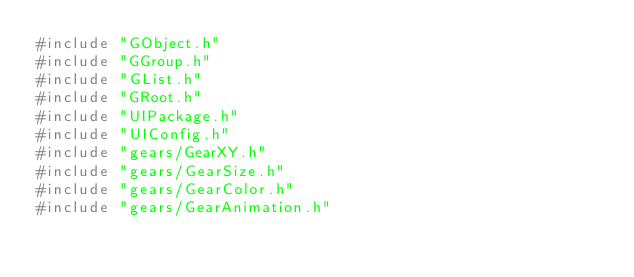<code> <loc_0><loc_0><loc_500><loc_500><_C++_>#include "GObject.h"
#include "GGroup.h"
#include "GList.h"
#include "GRoot.h"
#include "UIPackage.h"
#include "UIConfig.h"
#include "gears/GearXY.h"
#include "gears/GearSize.h"
#include "gears/GearColor.h"
#include "gears/GearAnimation.h"</code> 